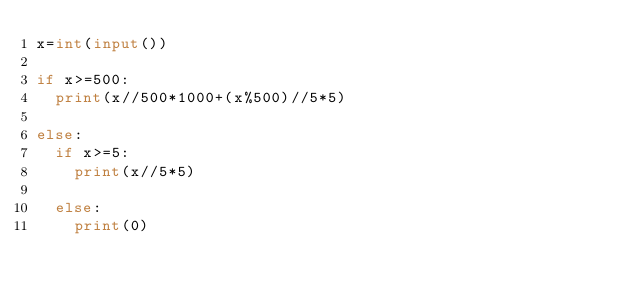<code> <loc_0><loc_0><loc_500><loc_500><_Python_>x=int(input())

if x>=500:
  print(x//500*1000+(x%500)//5*5)
  
else:
  if x>=5:
    print(x//5*5)
    
  else:
    print(0)</code> 